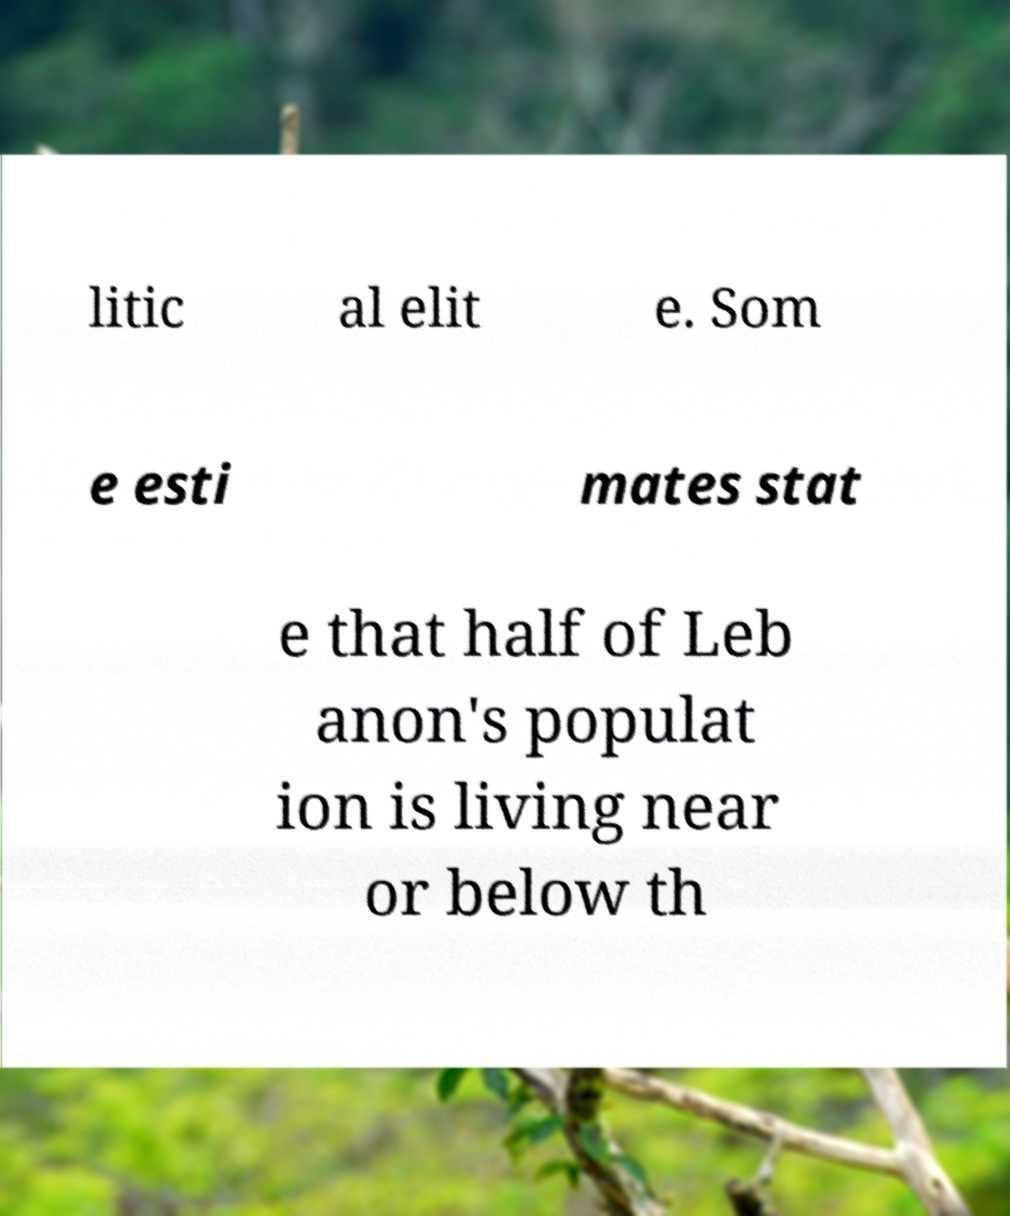Could you extract and type out the text from this image? litic al elit e. Som e esti mates stat e that half of Leb anon's populat ion is living near or below th 